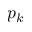<formula> <loc_0><loc_0><loc_500><loc_500>p _ { k }</formula> 